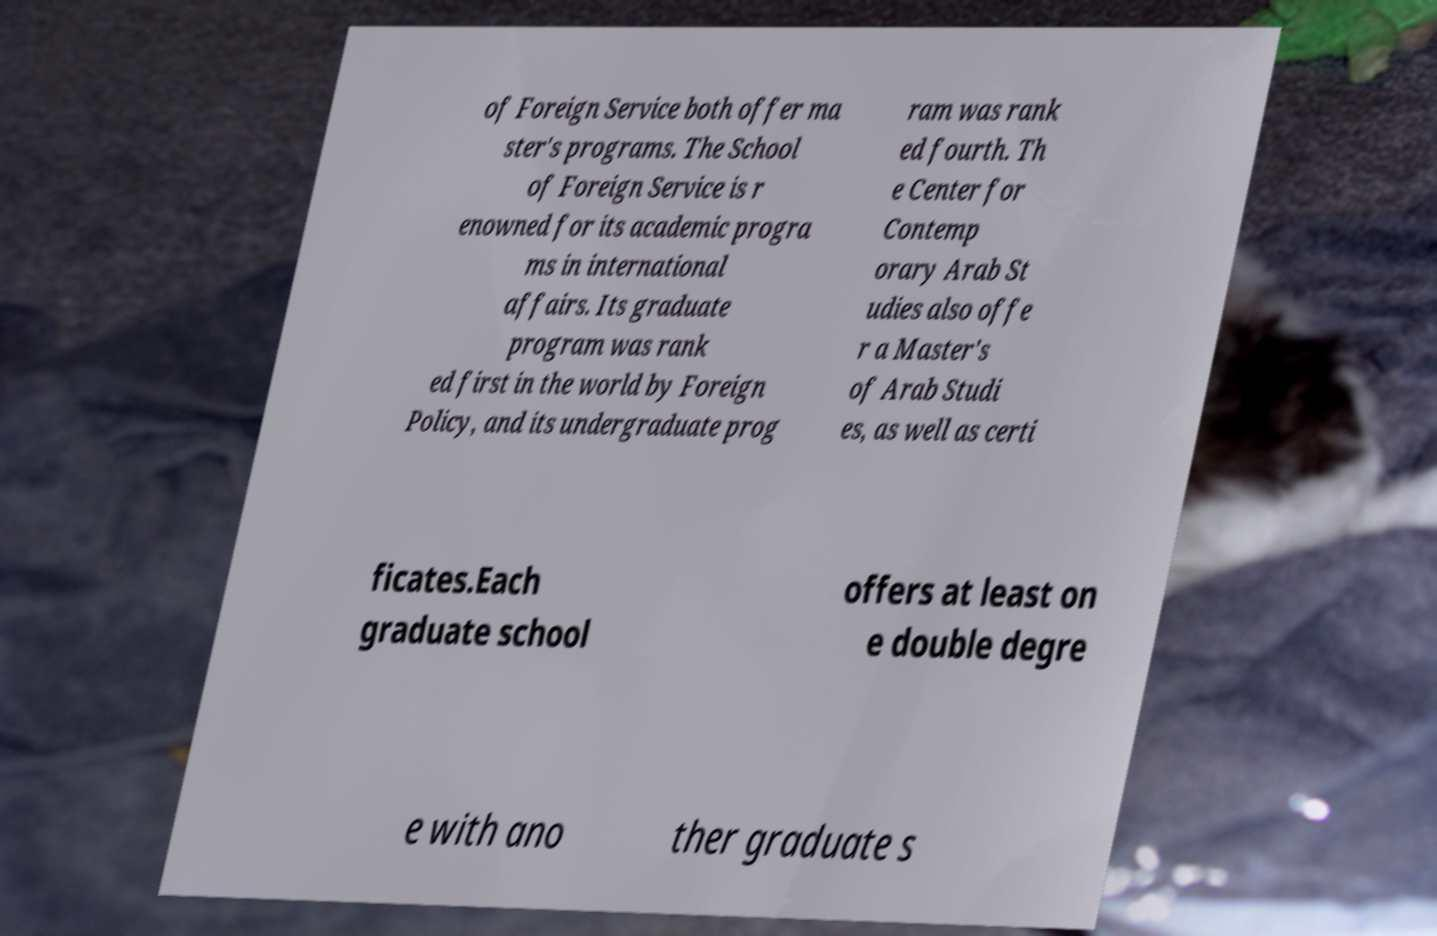Please identify and transcribe the text found in this image. of Foreign Service both offer ma ster's programs. The School of Foreign Service is r enowned for its academic progra ms in international affairs. Its graduate program was rank ed first in the world by Foreign Policy, and its undergraduate prog ram was rank ed fourth. Th e Center for Contemp orary Arab St udies also offe r a Master's of Arab Studi es, as well as certi ficates.Each graduate school offers at least on e double degre e with ano ther graduate s 